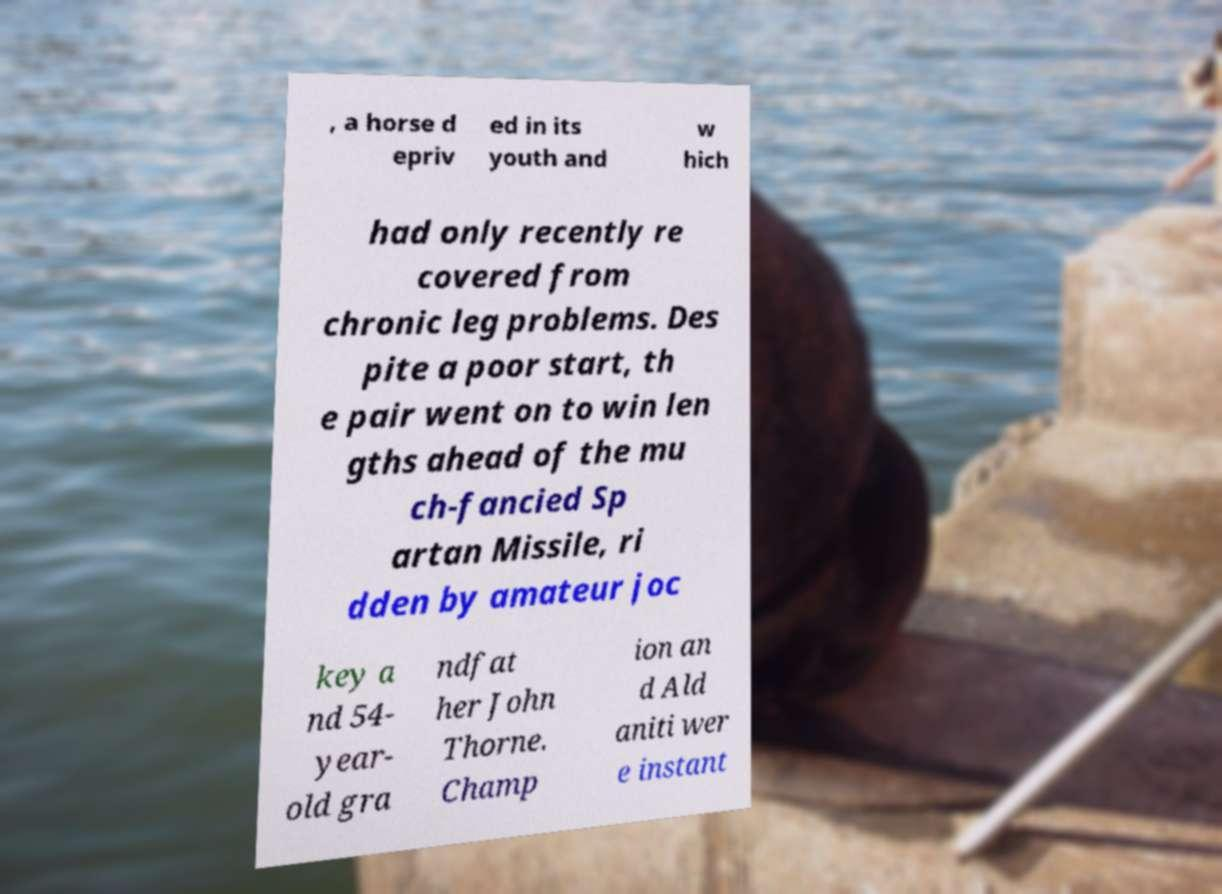Please read and relay the text visible in this image. What does it say? , a horse d epriv ed in its youth and w hich had only recently re covered from chronic leg problems. Des pite a poor start, th e pair went on to win len gths ahead of the mu ch-fancied Sp artan Missile, ri dden by amateur joc key a nd 54- year- old gra ndfat her John Thorne. Champ ion an d Ald aniti wer e instant 